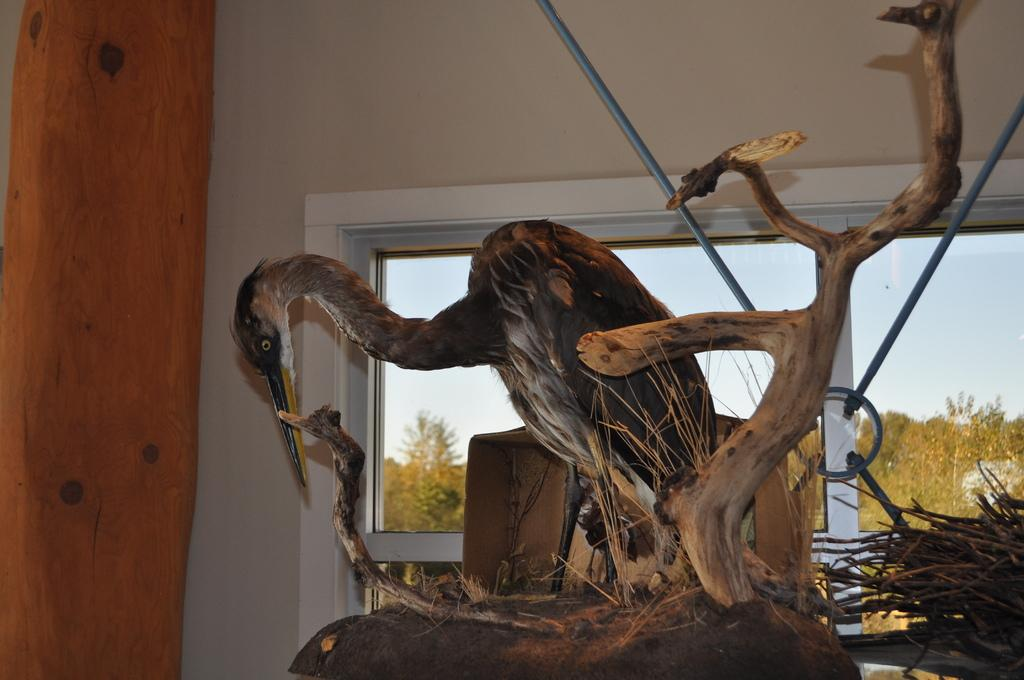What type of animal can be seen in the image? There is a bird in the image. What is the bird standing on? The bird is standing on a tree trunk in the image. What other objects are made of wood in the image? There are wood sticks in the image. What can be seen in the background of the image? There is a wall, a window, trees, and the sky visible in the background of the image. Can you describe the setting of the image? The image may have been taken in a room, as there is a wall and window visible in the background. What type of balls can be seen bouncing around in the image? There are no balls present in the image. What sound can be heard coming from the sky in the image? There is no sound mentioned in the image, and the sky is visible but not audible. 